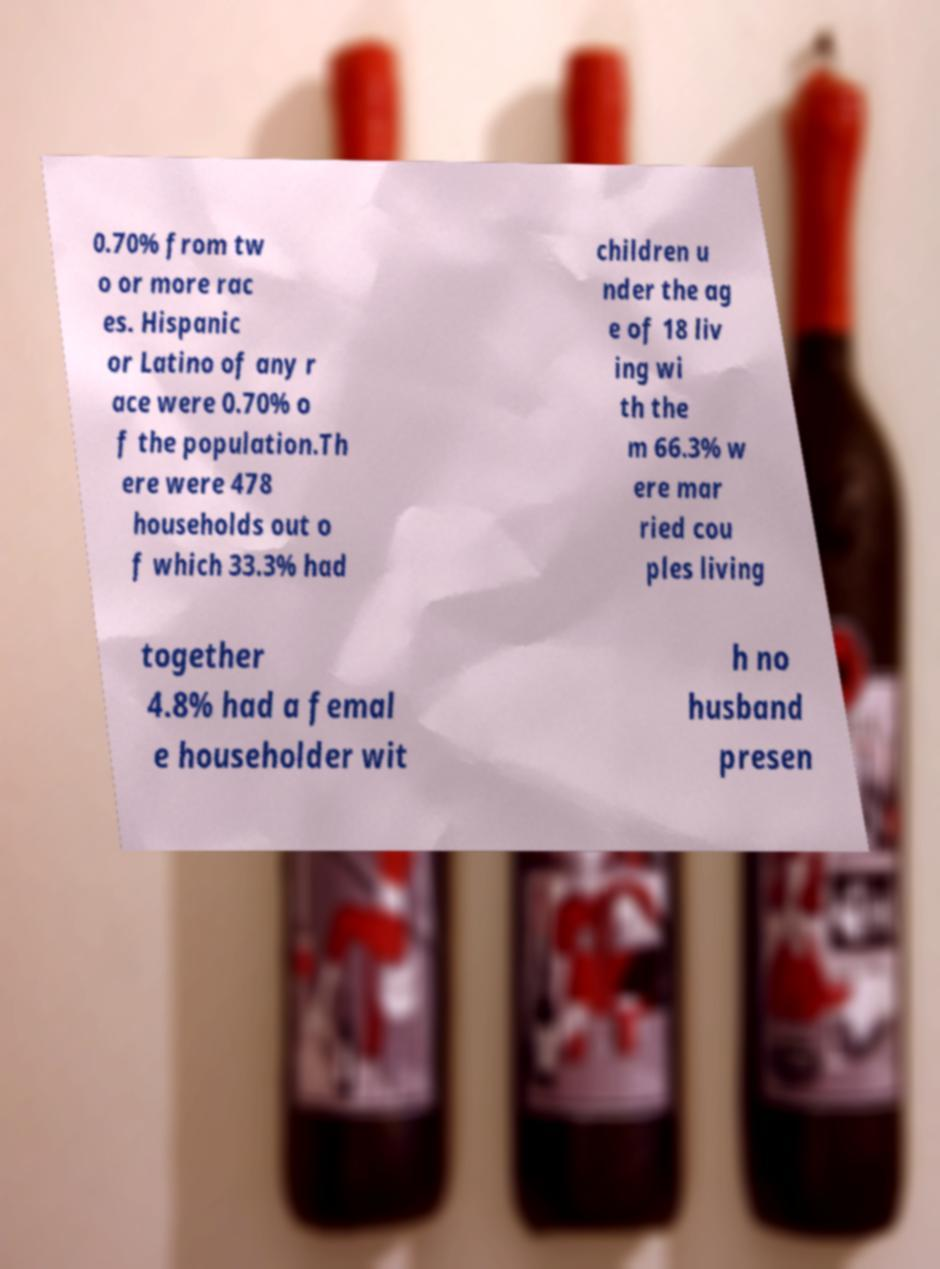Can you read and provide the text displayed in the image?This photo seems to have some interesting text. Can you extract and type it out for me? 0.70% from tw o or more rac es. Hispanic or Latino of any r ace were 0.70% o f the population.Th ere were 478 households out o f which 33.3% had children u nder the ag e of 18 liv ing wi th the m 66.3% w ere mar ried cou ples living together 4.8% had a femal e householder wit h no husband presen 